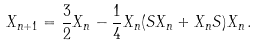<formula> <loc_0><loc_0><loc_500><loc_500>X _ { n + 1 } = \frac { 3 } { 2 } X _ { n } - \frac { 1 } { 4 } X _ { n } ( S X _ { n } + X _ { n } S ) X _ { n } \, .</formula> 